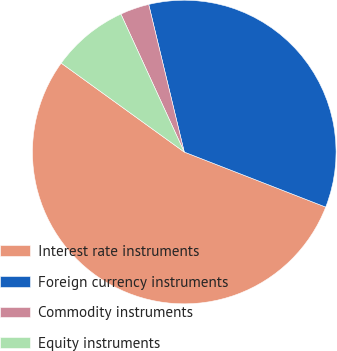Convert chart to OTSL. <chart><loc_0><loc_0><loc_500><loc_500><pie_chart><fcel>Interest rate instruments<fcel>Foreign currency instruments<fcel>Commodity instruments<fcel>Equity instruments<nl><fcel>54.05%<fcel>34.67%<fcel>3.09%<fcel>8.19%<nl></chart> 